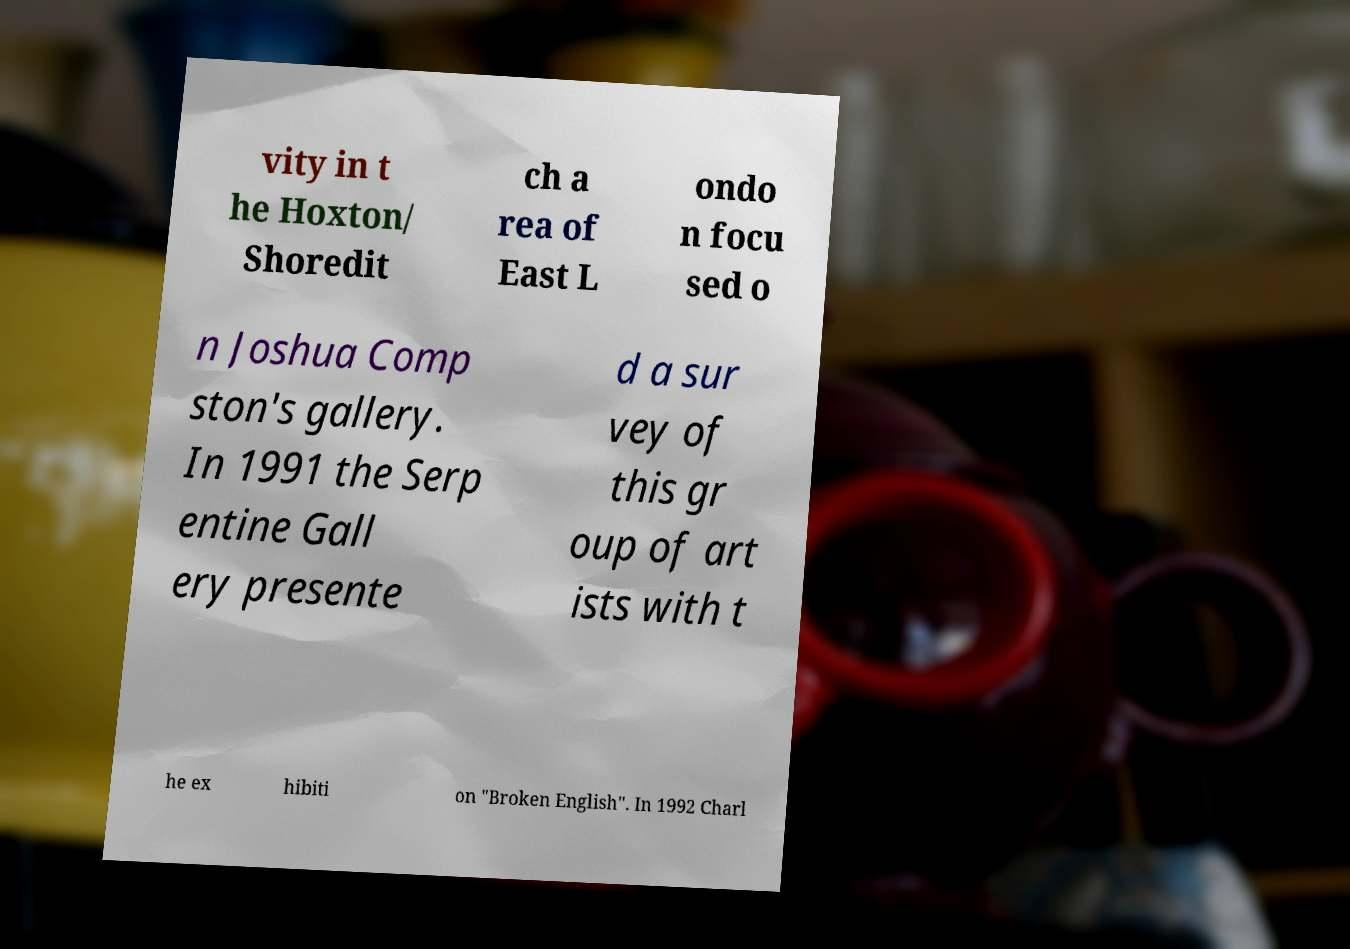There's text embedded in this image that I need extracted. Can you transcribe it verbatim? vity in t he Hoxton/ Shoredit ch a rea of East L ondo n focu sed o n Joshua Comp ston's gallery. In 1991 the Serp entine Gall ery presente d a sur vey of this gr oup of art ists with t he ex hibiti on "Broken English". In 1992 Charl 